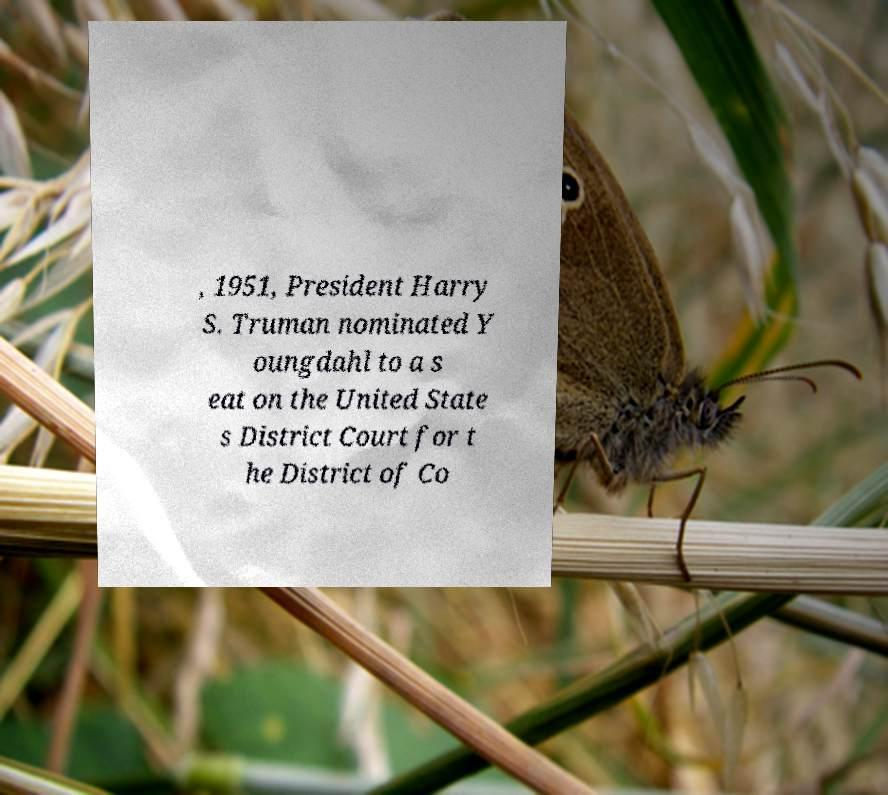Could you assist in decoding the text presented in this image and type it out clearly? , 1951, President Harry S. Truman nominated Y oungdahl to a s eat on the United State s District Court for t he District of Co 